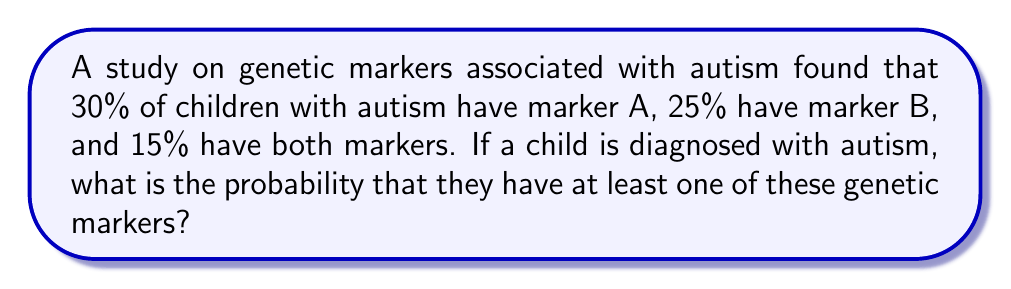Help me with this question. Let's approach this step-by-step using the principles of probability:

1) Let's define our events:
   A: Child has marker A
   B: Child has marker B

2) We're given the following probabilities:
   $P(A) = 0.30$
   $P(B) = 0.25$
   $P(A \cap B) = 0.15$ (probability of having both markers)

3) We need to find $P(A \cup B)$, the probability of having at least one marker.

4) We can use the addition rule of probability:
   $P(A \cup B) = P(A) + P(B) - P(A \cap B)$

5) Substituting the values:
   $P(A \cup B) = 0.30 + 0.25 - 0.15$

6) Calculating:
   $P(A \cup B) = 0.40$ or 40%

Therefore, the probability that a child with autism has at least one of these genetic markers is 0.40 or 40%.
Answer: 0.40 or 40% 